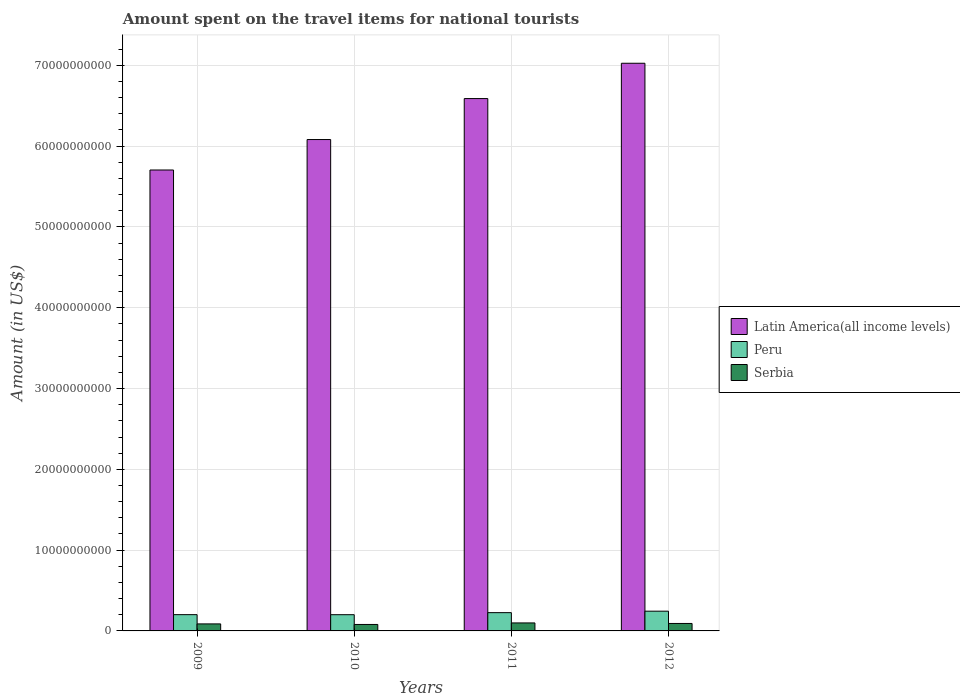How many groups of bars are there?
Your answer should be very brief. 4. Are the number of bars per tick equal to the number of legend labels?
Your answer should be very brief. Yes. Are the number of bars on each tick of the X-axis equal?
Your answer should be compact. Yes. How many bars are there on the 4th tick from the right?
Offer a very short reply. 3. In how many cases, is the number of bars for a given year not equal to the number of legend labels?
Your answer should be very brief. 0. What is the amount spent on the travel items for national tourists in Serbia in 2012?
Keep it short and to the point. 9.24e+08. Across all years, what is the maximum amount spent on the travel items for national tourists in Serbia?
Ensure brevity in your answer.  9.90e+08. Across all years, what is the minimum amount spent on the travel items for national tourists in Latin America(all income levels)?
Provide a short and direct response. 5.70e+1. What is the total amount spent on the travel items for national tourists in Latin America(all income levels) in the graph?
Give a very brief answer. 2.54e+11. What is the difference between the amount spent on the travel items for national tourists in Serbia in 2010 and that in 2012?
Provide a succinct answer. -1.25e+08. What is the difference between the amount spent on the travel items for national tourists in Serbia in 2011 and the amount spent on the travel items for national tourists in Peru in 2012?
Offer a terse response. -1.45e+09. What is the average amount spent on the travel items for national tourists in Peru per year?
Offer a very short reply. 2.18e+09. In the year 2011, what is the difference between the amount spent on the travel items for national tourists in Peru and amount spent on the travel items for national tourists in Serbia?
Your response must be concise. 1.27e+09. What is the ratio of the amount spent on the travel items for national tourists in Latin America(all income levels) in 2011 to that in 2012?
Provide a succinct answer. 0.94. Is the amount spent on the travel items for national tourists in Serbia in 2009 less than that in 2012?
Give a very brief answer. Yes. What is the difference between the highest and the second highest amount spent on the travel items for national tourists in Peru?
Keep it short and to the point. 1.81e+08. What is the difference between the highest and the lowest amount spent on the travel items for national tourists in Latin America(all income levels)?
Ensure brevity in your answer.  1.32e+1. In how many years, is the amount spent on the travel items for national tourists in Serbia greater than the average amount spent on the travel items for national tourists in Serbia taken over all years?
Offer a terse response. 2. Is the sum of the amount spent on the travel items for national tourists in Serbia in 2009 and 2012 greater than the maximum amount spent on the travel items for national tourists in Peru across all years?
Offer a terse response. No. What does the 3rd bar from the left in 2010 represents?
Provide a short and direct response. Serbia. What does the 1st bar from the right in 2009 represents?
Offer a terse response. Serbia. How many bars are there?
Provide a short and direct response. 12. Are all the bars in the graph horizontal?
Provide a short and direct response. No. How many years are there in the graph?
Offer a terse response. 4. Does the graph contain any zero values?
Ensure brevity in your answer.  No. Does the graph contain grids?
Your answer should be very brief. Yes. How are the legend labels stacked?
Your response must be concise. Vertical. What is the title of the graph?
Provide a short and direct response. Amount spent on the travel items for national tourists. Does "Paraguay" appear as one of the legend labels in the graph?
Provide a succinct answer. No. What is the label or title of the X-axis?
Offer a very short reply. Years. What is the Amount (in US$) of Latin America(all income levels) in 2009?
Your response must be concise. 5.70e+1. What is the Amount (in US$) of Peru in 2009?
Give a very brief answer. 2.01e+09. What is the Amount (in US$) of Serbia in 2009?
Make the answer very short. 8.69e+08. What is the Amount (in US$) of Latin America(all income levels) in 2010?
Offer a terse response. 6.08e+1. What is the Amount (in US$) in Peru in 2010?
Make the answer very short. 2.01e+09. What is the Amount (in US$) in Serbia in 2010?
Ensure brevity in your answer.  7.99e+08. What is the Amount (in US$) of Latin America(all income levels) in 2011?
Ensure brevity in your answer.  6.59e+1. What is the Amount (in US$) of Peru in 2011?
Offer a very short reply. 2.26e+09. What is the Amount (in US$) of Serbia in 2011?
Your response must be concise. 9.90e+08. What is the Amount (in US$) in Latin America(all income levels) in 2012?
Your response must be concise. 7.03e+1. What is the Amount (in US$) in Peru in 2012?
Your answer should be compact. 2.44e+09. What is the Amount (in US$) of Serbia in 2012?
Your response must be concise. 9.24e+08. Across all years, what is the maximum Amount (in US$) of Latin America(all income levels)?
Provide a short and direct response. 7.03e+1. Across all years, what is the maximum Amount (in US$) of Peru?
Keep it short and to the point. 2.44e+09. Across all years, what is the maximum Amount (in US$) of Serbia?
Your answer should be very brief. 9.90e+08. Across all years, what is the minimum Amount (in US$) of Latin America(all income levels)?
Give a very brief answer. 5.70e+1. Across all years, what is the minimum Amount (in US$) in Peru?
Offer a very short reply. 2.01e+09. Across all years, what is the minimum Amount (in US$) of Serbia?
Your answer should be very brief. 7.99e+08. What is the total Amount (in US$) of Latin America(all income levels) in the graph?
Provide a short and direct response. 2.54e+11. What is the total Amount (in US$) of Peru in the graph?
Provide a short and direct response. 8.73e+09. What is the total Amount (in US$) of Serbia in the graph?
Your answer should be very brief. 3.58e+09. What is the difference between the Amount (in US$) of Latin America(all income levels) in 2009 and that in 2010?
Keep it short and to the point. -3.77e+09. What is the difference between the Amount (in US$) of Peru in 2009 and that in 2010?
Provide a short and direct response. 6.00e+06. What is the difference between the Amount (in US$) of Serbia in 2009 and that in 2010?
Keep it short and to the point. 7.00e+07. What is the difference between the Amount (in US$) of Latin America(all income levels) in 2009 and that in 2011?
Provide a succinct answer. -8.84e+09. What is the difference between the Amount (in US$) in Peru in 2009 and that in 2011?
Offer a very short reply. -2.48e+08. What is the difference between the Amount (in US$) of Serbia in 2009 and that in 2011?
Provide a succinct answer. -1.21e+08. What is the difference between the Amount (in US$) in Latin America(all income levels) in 2009 and that in 2012?
Offer a terse response. -1.32e+1. What is the difference between the Amount (in US$) of Peru in 2009 and that in 2012?
Give a very brief answer. -4.29e+08. What is the difference between the Amount (in US$) of Serbia in 2009 and that in 2012?
Provide a succinct answer. -5.50e+07. What is the difference between the Amount (in US$) of Latin America(all income levels) in 2010 and that in 2011?
Keep it short and to the point. -5.07e+09. What is the difference between the Amount (in US$) in Peru in 2010 and that in 2011?
Your response must be concise. -2.54e+08. What is the difference between the Amount (in US$) in Serbia in 2010 and that in 2011?
Give a very brief answer. -1.91e+08. What is the difference between the Amount (in US$) in Latin America(all income levels) in 2010 and that in 2012?
Your response must be concise. -9.44e+09. What is the difference between the Amount (in US$) in Peru in 2010 and that in 2012?
Your answer should be compact. -4.35e+08. What is the difference between the Amount (in US$) in Serbia in 2010 and that in 2012?
Offer a terse response. -1.25e+08. What is the difference between the Amount (in US$) of Latin America(all income levels) in 2011 and that in 2012?
Your response must be concise. -4.37e+09. What is the difference between the Amount (in US$) in Peru in 2011 and that in 2012?
Your answer should be compact. -1.81e+08. What is the difference between the Amount (in US$) in Serbia in 2011 and that in 2012?
Offer a very short reply. 6.60e+07. What is the difference between the Amount (in US$) of Latin America(all income levels) in 2009 and the Amount (in US$) of Peru in 2010?
Provide a succinct answer. 5.50e+1. What is the difference between the Amount (in US$) in Latin America(all income levels) in 2009 and the Amount (in US$) in Serbia in 2010?
Make the answer very short. 5.62e+1. What is the difference between the Amount (in US$) of Peru in 2009 and the Amount (in US$) of Serbia in 2010?
Provide a short and direct response. 1.22e+09. What is the difference between the Amount (in US$) of Latin America(all income levels) in 2009 and the Amount (in US$) of Peru in 2011?
Make the answer very short. 5.48e+1. What is the difference between the Amount (in US$) in Latin America(all income levels) in 2009 and the Amount (in US$) in Serbia in 2011?
Ensure brevity in your answer.  5.61e+1. What is the difference between the Amount (in US$) of Peru in 2009 and the Amount (in US$) of Serbia in 2011?
Your answer should be compact. 1.02e+09. What is the difference between the Amount (in US$) in Latin America(all income levels) in 2009 and the Amount (in US$) in Peru in 2012?
Offer a very short reply. 5.46e+1. What is the difference between the Amount (in US$) of Latin America(all income levels) in 2009 and the Amount (in US$) of Serbia in 2012?
Your answer should be compact. 5.61e+1. What is the difference between the Amount (in US$) of Peru in 2009 and the Amount (in US$) of Serbia in 2012?
Provide a short and direct response. 1.09e+09. What is the difference between the Amount (in US$) of Latin America(all income levels) in 2010 and the Amount (in US$) of Peru in 2011?
Your answer should be very brief. 5.86e+1. What is the difference between the Amount (in US$) in Latin America(all income levels) in 2010 and the Amount (in US$) in Serbia in 2011?
Your answer should be compact. 5.98e+1. What is the difference between the Amount (in US$) in Peru in 2010 and the Amount (in US$) in Serbia in 2011?
Your answer should be very brief. 1.02e+09. What is the difference between the Amount (in US$) in Latin America(all income levels) in 2010 and the Amount (in US$) in Peru in 2012?
Your answer should be very brief. 5.84e+1. What is the difference between the Amount (in US$) of Latin America(all income levels) in 2010 and the Amount (in US$) of Serbia in 2012?
Provide a succinct answer. 5.99e+1. What is the difference between the Amount (in US$) in Peru in 2010 and the Amount (in US$) in Serbia in 2012?
Offer a very short reply. 1.08e+09. What is the difference between the Amount (in US$) in Latin America(all income levels) in 2011 and the Amount (in US$) in Peru in 2012?
Keep it short and to the point. 6.34e+1. What is the difference between the Amount (in US$) in Latin America(all income levels) in 2011 and the Amount (in US$) in Serbia in 2012?
Make the answer very short. 6.50e+1. What is the difference between the Amount (in US$) in Peru in 2011 and the Amount (in US$) in Serbia in 2012?
Keep it short and to the point. 1.34e+09. What is the average Amount (in US$) in Latin America(all income levels) per year?
Offer a very short reply. 6.35e+1. What is the average Amount (in US$) in Peru per year?
Ensure brevity in your answer.  2.18e+09. What is the average Amount (in US$) of Serbia per year?
Your answer should be very brief. 8.96e+08. In the year 2009, what is the difference between the Amount (in US$) of Latin America(all income levels) and Amount (in US$) of Peru?
Your answer should be very brief. 5.50e+1. In the year 2009, what is the difference between the Amount (in US$) of Latin America(all income levels) and Amount (in US$) of Serbia?
Your answer should be compact. 5.62e+1. In the year 2009, what is the difference between the Amount (in US$) in Peru and Amount (in US$) in Serbia?
Your response must be concise. 1.14e+09. In the year 2010, what is the difference between the Amount (in US$) of Latin America(all income levels) and Amount (in US$) of Peru?
Give a very brief answer. 5.88e+1. In the year 2010, what is the difference between the Amount (in US$) in Latin America(all income levels) and Amount (in US$) in Serbia?
Ensure brevity in your answer.  6.00e+1. In the year 2010, what is the difference between the Amount (in US$) of Peru and Amount (in US$) of Serbia?
Your answer should be very brief. 1.21e+09. In the year 2011, what is the difference between the Amount (in US$) in Latin America(all income levels) and Amount (in US$) in Peru?
Your answer should be very brief. 6.36e+1. In the year 2011, what is the difference between the Amount (in US$) in Latin America(all income levels) and Amount (in US$) in Serbia?
Offer a terse response. 6.49e+1. In the year 2011, what is the difference between the Amount (in US$) of Peru and Amount (in US$) of Serbia?
Make the answer very short. 1.27e+09. In the year 2012, what is the difference between the Amount (in US$) in Latin America(all income levels) and Amount (in US$) in Peru?
Offer a very short reply. 6.78e+1. In the year 2012, what is the difference between the Amount (in US$) of Latin America(all income levels) and Amount (in US$) of Serbia?
Your answer should be very brief. 6.93e+1. In the year 2012, what is the difference between the Amount (in US$) of Peru and Amount (in US$) of Serbia?
Give a very brief answer. 1.52e+09. What is the ratio of the Amount (in US$) in Latin America(all income levels) in 2009 to that in 2010?
Your answer should be compact. 0.94. What is the ratio of the Amount (in US$) in Serbia in 2009 to that in 2010?
Ensure brevity in your answer.  1.09. What is the ratio of the Amount (in US$) of Latin America(all income levels) in 2009 to that in 2011?
Your answer should be compact. 0.87. What is the ratio of the Amount (in US$) of Peru in 2009 to that in 2011?
Offer a terse response. 0.89. What is the ratio of the Amount (in US$) in Serbia in 2009 to that in 2011?
Keep it short and to the point. 0.88. What is the ratio of the Amount (in US$) of Latin America(all income levels) in 2009 to that in 2012?
Your answer should be very brief. 0.81. What is the ratio of the Amount (in US$) in Peru in 2009 to that in 2012?
Give a very brief answer. 0.82. What is the ratio of the Amount (in US$) of Serbia in 2009 to that in 2012?
Your response must be concise. 0.94. What is the ratio of the Amount (in US$) of Latin America(all income levels) in 2010 to that in 2011?
Your response must be concise. 0.92. What is the ratio of the Amount (in US$) of Peru in 2010 to that in 2011?
Your answer should be compact. 0.89. What is the ratio of the Amount (in US$) in Serbia in 2010 to that in 2011?
Your answer should be compact. 0.81. What is the ratio of the Amount (in US$) of Latin America(all income levels) in 2010 to that in 2012?
Provide a succinct answer. 0.87. What is the ratio of the Amount (in US$) in Peru in 2010 to that in 2012?
Give a very brief answer. 0.82. What is the ratio of the Amount (in US$) of Serbia in 2010 to that in 2012?
Make the answer very short. 0.86. What is the ratio of the Amount (in US$) of Latin America(all income levels) in 2011 to that in 2012?
Make the answer very short. 0.94. What is the ratio of the Amount (in US$) in Peru in 2011 to that in 2012?
Make the answer very short. 0.93. What is the ratio of the Amount (in US$) of Serbia in 2011 to that in 2012?
Make the answer very short. 1.07. What is the difference between the highest and the second highest Amount (in US$) in Latin America(all income levels)?
Give a very brief answer. 4.37e+09. What is the difference between the highest and the second highest Amount (in US$) in Peru?
Ensure brevity in your answer.  1.81e+08. What is the difference between the highest and the second highest Amount (in US$) in Serbia?
Ensure brevity in your answer.  6.60e+07. What is the difference between the highest and the lowest Amount (in US$) of Latin America(all income levels)?
Provide a short and direct response. 1.32e+1. What is the difference between the highest and the lowest Amount (in US$) in Peru?
Offer a very short reply. 4.35e+08. What is the difference between the highest and the lowest Amount (in US$) of Serbia?
Offer a terse response. 1.91e+08. 